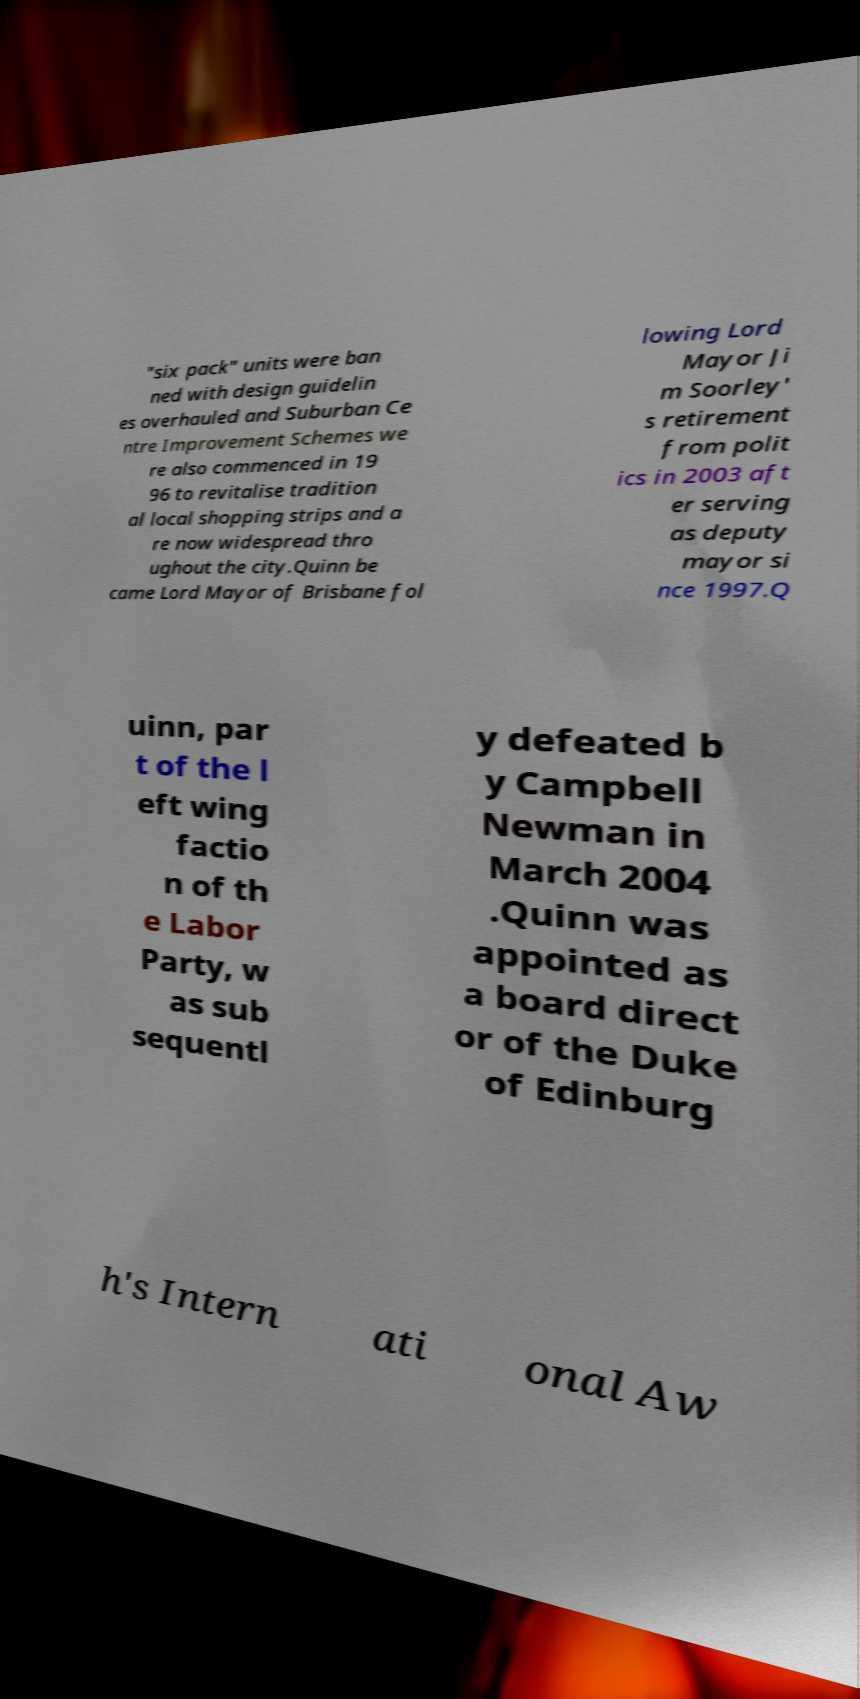Can you accurately transcribe the text from the provided image for me? "six pack" units were ban ned with design guidelin es overhauled and Suburban Ce ntre Improvement Schemes we re also commenced in 19 96 to revitalise tradition al local shopping strips and a re now widespread thro ughout the city.Quinn be came Lord Mayor of Brisbane fol lowing Lord Mayor Ji m Soorley' s retirement from polit ics in 2003 aft er serving as deputy mayor si nce 1997.Q uinn, par t of the l eft wing factio n of th e Labor Party, w as sub sequentl y defeated b y Campbell Newman in March 2004 .Quinn was appointed as a board direct or of the Duke of Edinburg h's Intern ati onal Aw 